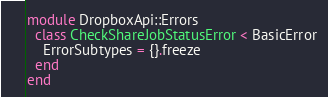<code> <loc_0><loc_0><loc_500><loc_500><_Ruby_>module DropboxApi::Errors
  class CheckShareJobStatusError < BasicError
    ErrorSubtypes = {}.freeze
  end
end
</code> 